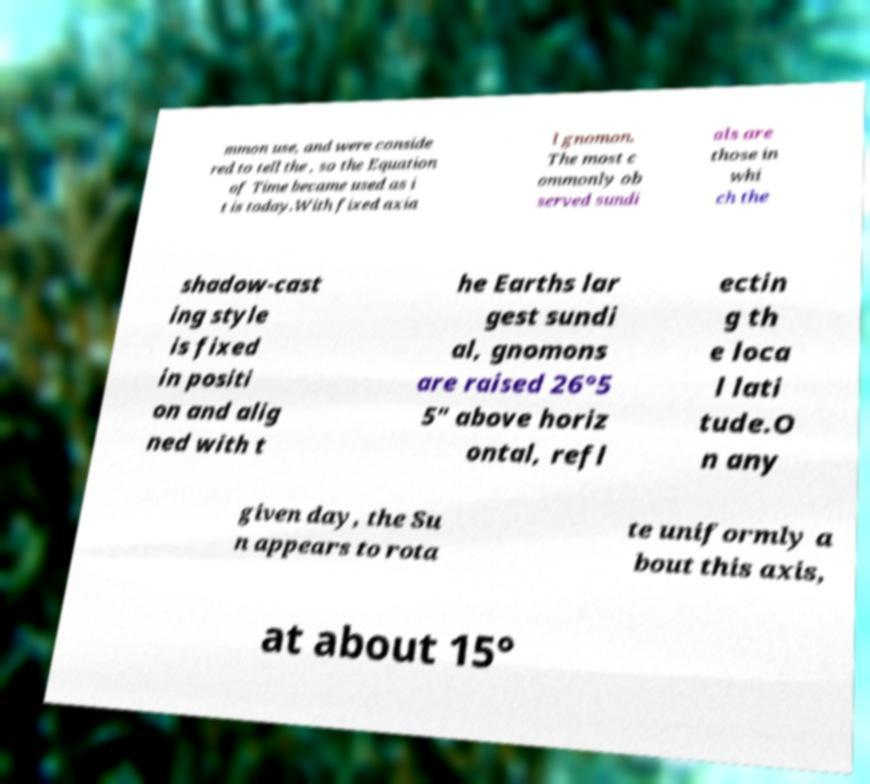Please identify and transcribe the text found in this image. mmon use, and were conside red to tell the , so the Equation of Time became used as i t is today.With fixed axia l gnomon. The most c ommonly ob served sundi als are those in whi ch the shadow-cast ing style is fixed in positi on and alig ned with t he Earths lar gest sundi al, gnomons are raised 26°5 5" above horiz ontal, refl ectin g th e loca l lati tude.O n any given day, the Su n appears to rota te uniformly a bout this axis, at about 15° 